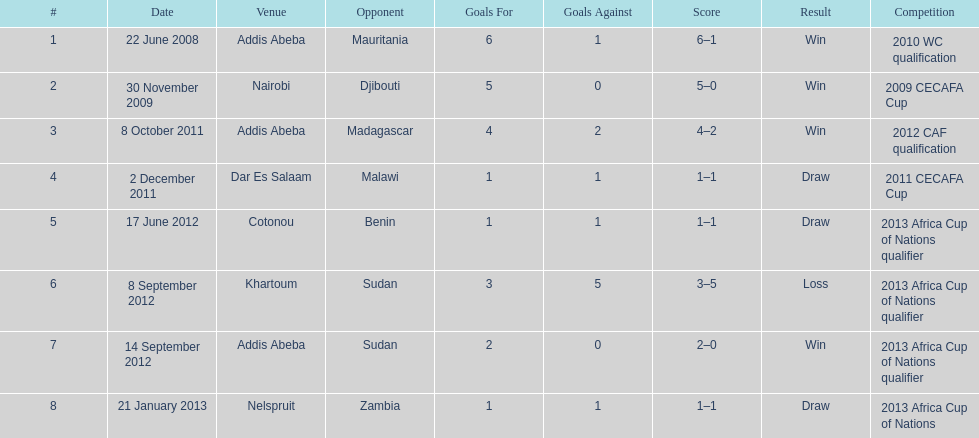For each winning game, what was their score? 6-1, 5-0, 4-2, 2-0. 